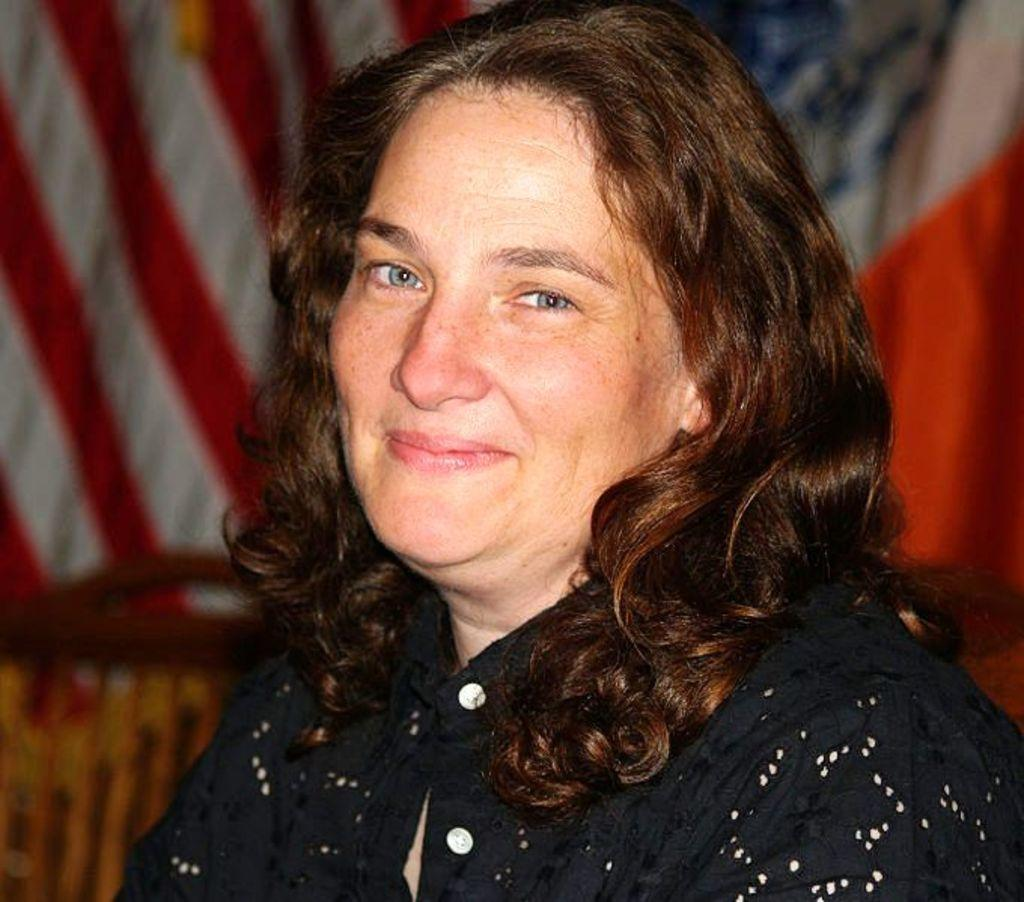Who is the main subject in the image? There is a woman in the image. What is the woman wearing? The woman is wearing a black dress. What can be seen in the background of the image? There are flags in the background of the image. What type of trouble is the woman causing in the image? There is no indication of trouble or any negative actions in the image; the woman is simply present and wearing a black dress. 